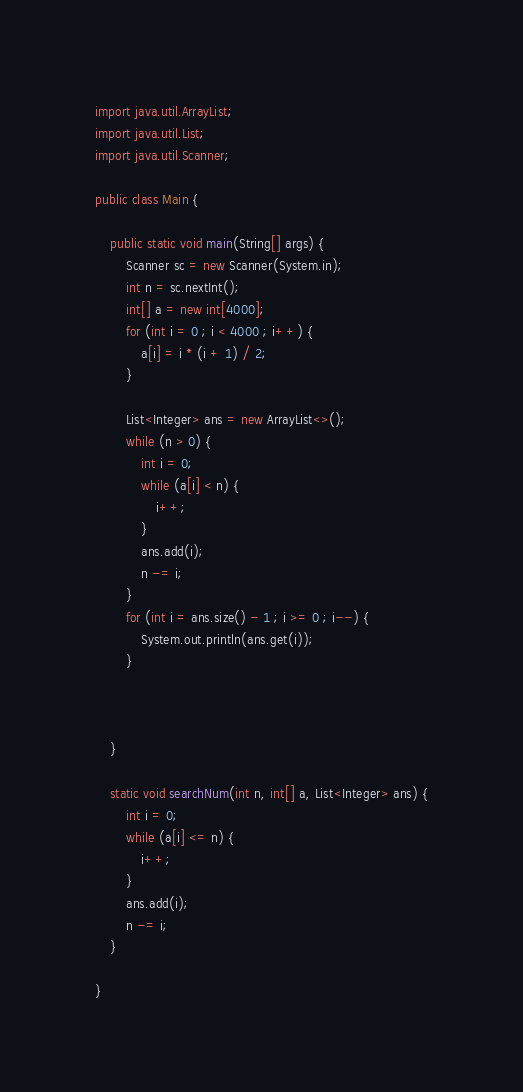Convert code to text. <code><loc_0><loc_0><loc_500><loc_500><_Java_>import java.util.ArrayList;
import java.util.List;
import java.util.Scanner;

public class Main {

    public static void main(String[] args) {
        Scanner sc = new Scanner(System.in);
        int n = sc.nextInt();
        int[] a = new int[4000];
        for (int i = 0 ; i < 4000 ; i++) {
            a[i] = i * (i + 1) / 2;
        }

        List<Integer> ans = new ArrayList<>();
        while (n > 0) {
            int i = 0;
            while (a[i] < n) {
                i++;
            }
            ans.add(i);
            n -= i;
        }
        for (int i = ans.size() - 1 ; i >= 0 ; i--) {
            System.out.println(ans.get(i));
        }



    }

    static void searchNum(int n, int[] a, List<Integer> ans) {
        int i = 0;
        while (a[i] <= n) {
            i++;
        }
        ans.add(i);
        n -= i;
    }

}</code> 